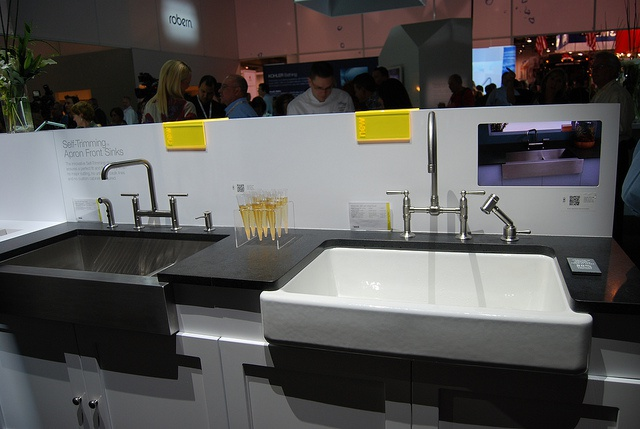Describe the objects in this image and their specific colors. I can see sink in black, lightgray, gray, and darkgray tones, people in black, gray, blue, and darkblue tones, sink in black and gray tones, people in black, darkgreen, and gray tones, and people in black, gray, and maroon tones in this image. 